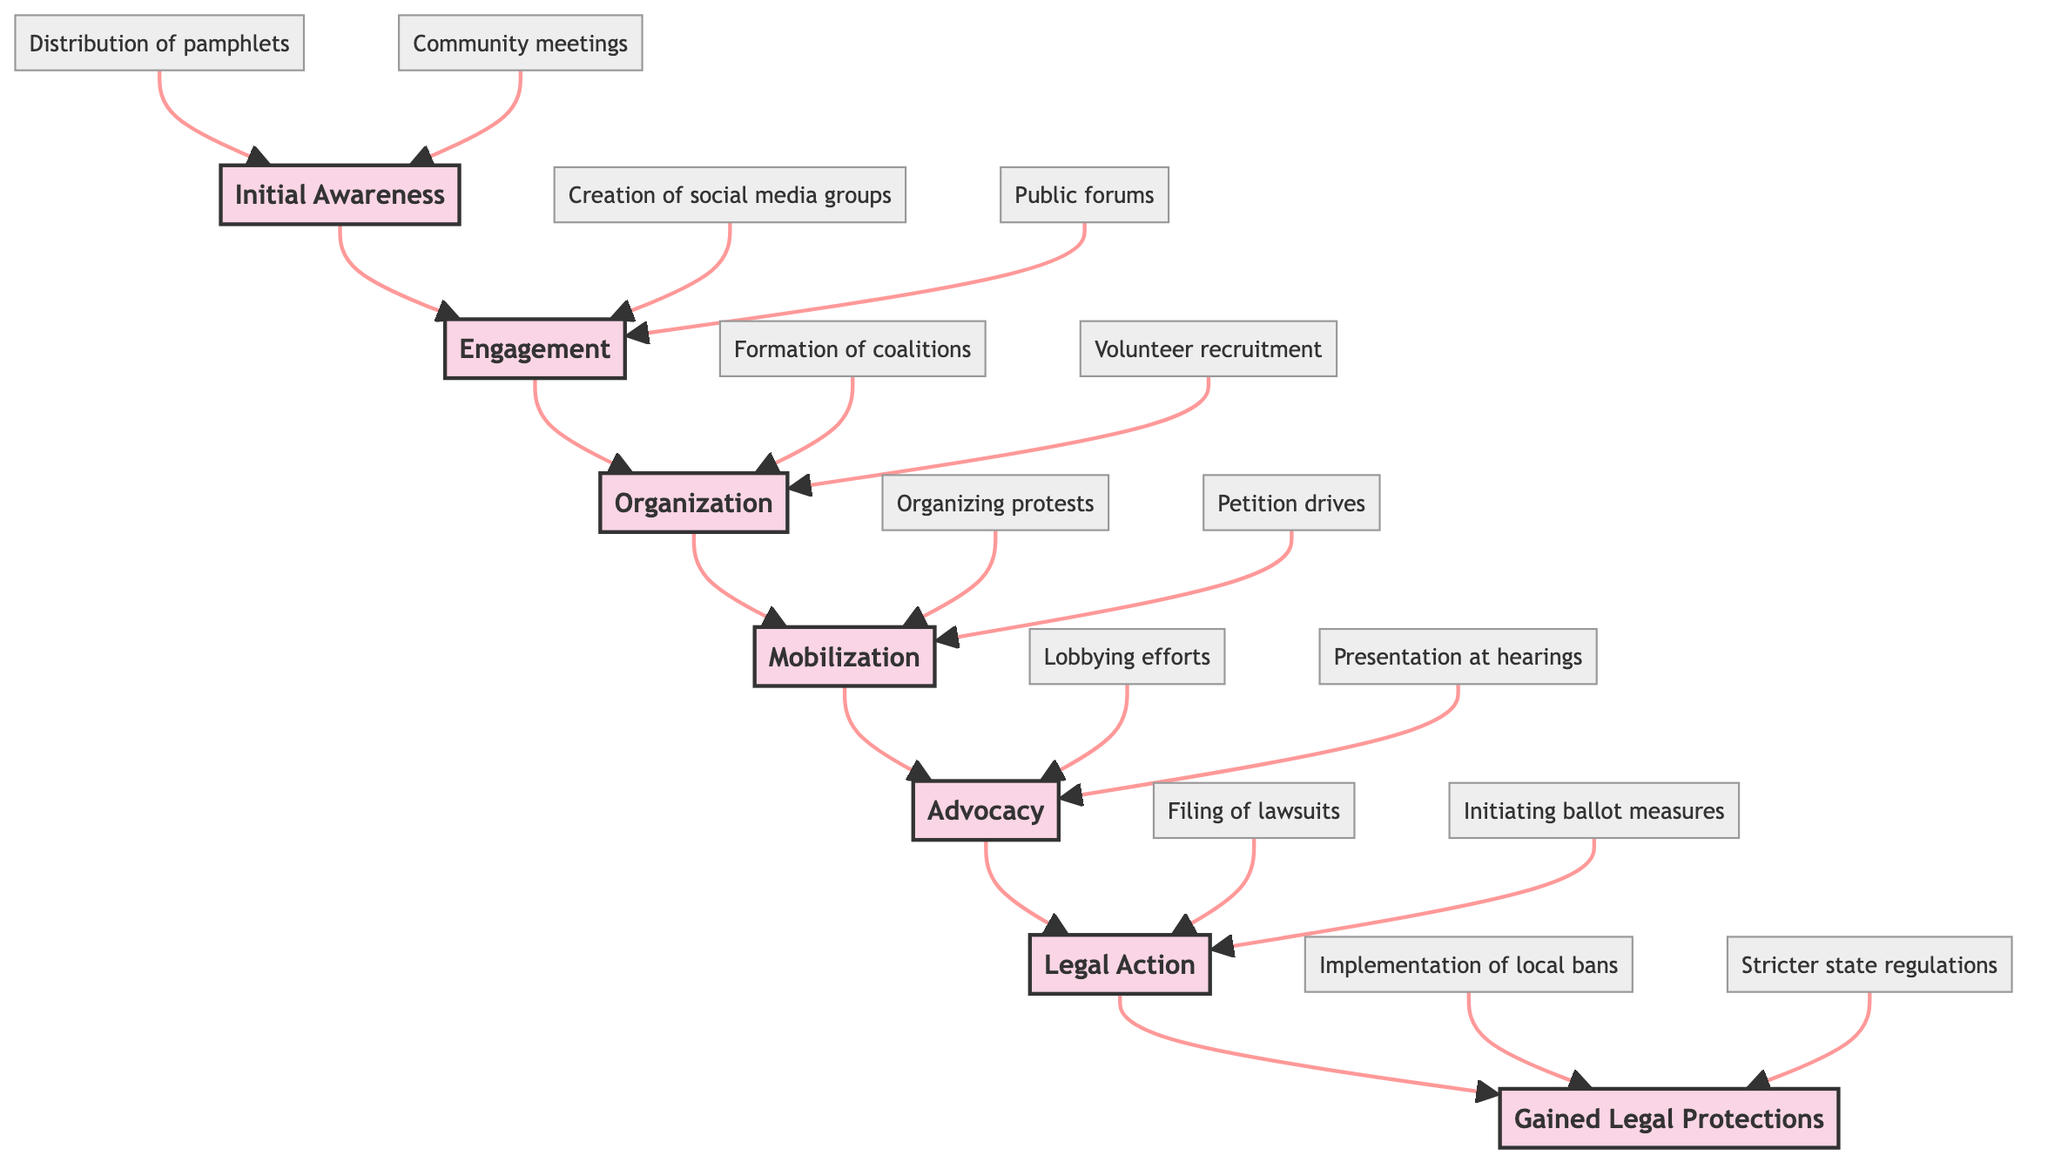What is the topmost level in the flow chart? The topmost level is "Gained Legal Protections," which is the final outcome of the citizen activism process depicted in the diagram.
Answer: Gained Legal Protections How many levels are represented in the diagram? The diagram includes seven distinct levels: Initial Awareness, Engagement, Organization, Mobilization, Advocacy, Legal Action, and Gained Legal Protections. This is determined by counting each level node in sequence.
Answer: Seven What activities are associated with the "Mobilization" level? The activities at the "Mobilization" level include "Organizing peaceful protests and rallies" and "Petition drives to gather signatures against fracking," which can be found in the corresponding section of the diagram.
Answer: Organizing peaceful protests and rallies, Petition drives to gather signatures against fracking Which level comes immediately before "Legal Action"? The level that comes immediately before "Legal Action" in the flow chart is "Advocacy," as there is a direct upward arrow connecting the two levels.
Answer: Advocacy What are the outcomes of the "Gained Legal Protections" level? The outcomes list includes "Implementation of local bans on hydraulic fracturing" and "Stricter state regulations on fracking operations," indicating the results of successful citizen activism.
Answer: Implementation of local bans on hydraulic fracturing, Stricter state regulations on fracking operations How many activities are listed under the "Engagement" level? There are two activities listed under "Engagement": "Creation of social media groups such as 'Stop Fracking Now'" and "Public forums and town hall discussions." Thus, the count is two.
Answer: Two What is the relationship between "Organization" and "Mobilization"? "Organization" is the preceding level to "Mobilization," meaning that activities within "Organization" must occur before moving on to "Mobilization" in the progression of citizen activism efforts.
Answer: Organization precedes Mobilization Which coalitions are formed during the "Organization" level? The coalitions formed during the "Organization" level include "Formation of coalitions like the Shale Justice Coalition" and "Volunteer recruitment and training workshops," indicating community structure building and volunteer engagement.
Answer: Formation of coalitions like the Shale Justice Coalition, Volunteer recruitment and training workshops 